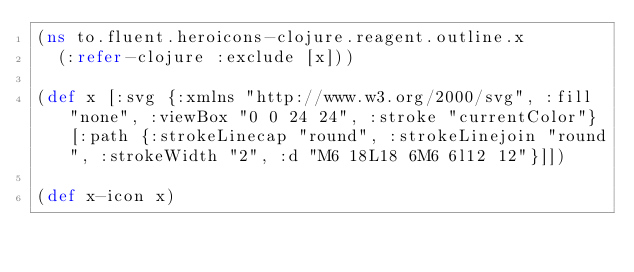<code> <loc_0><loc_0><loc_500><loc_500><_Clojure_>(ns to.fluent.heroicons-clojure.reagent.outline.x
  (:refer-clojure :exclude [x]))

(def x [:svg {:xmlns "http://www.w3.org/2000/svg", :fill "none", :viewBox "0 0 24 24", :stroke "currentColor"} [:path {:strokeLinecap "round", :strokeLinejoin "round", :strokeWidth "2", :d "M6 18L18 6M6 6l12 12"}]])

(def x-icon x)</code> 